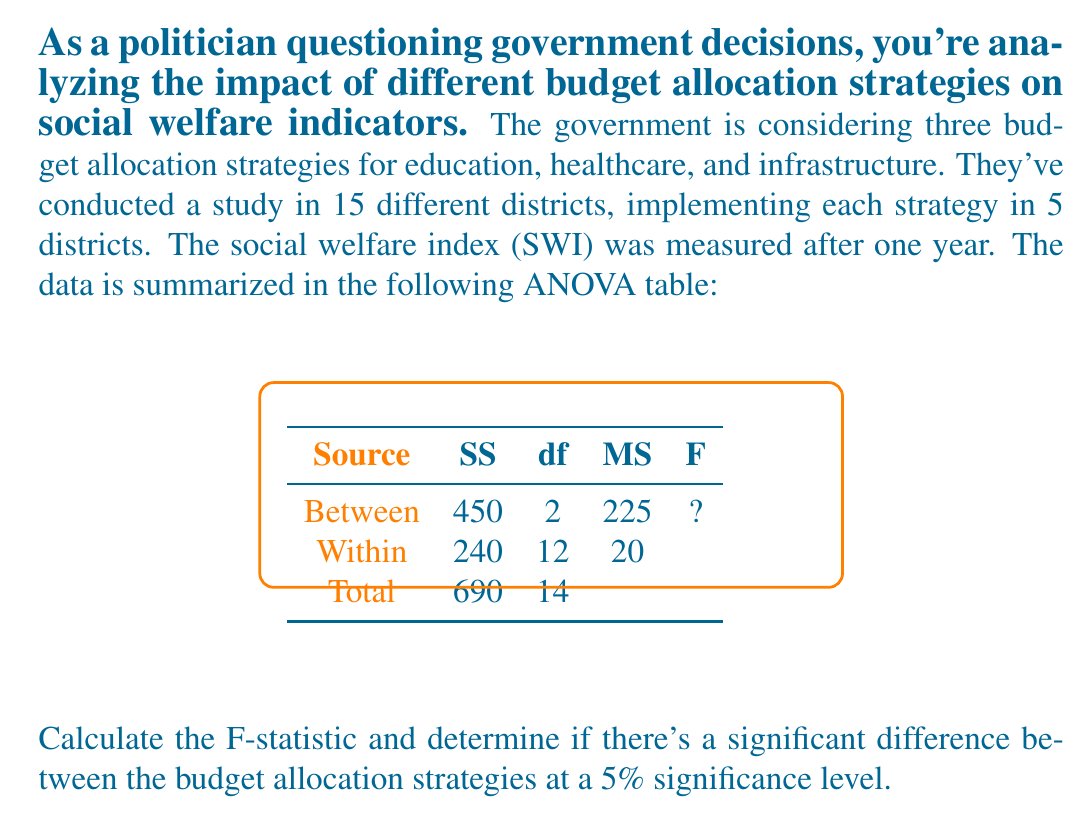Could you help me with this problem? Let's approach this step-by-step:

1) First, we need to calculate the F-statistic. The formula for F-statistic is:

   $$F = \frac{MS_{between}}{MS_{within}}$$

2) We can see from the ANOVA table that:
   $MS_{between} = 225$
   $MS_{within} = 20$

3) Plugging these values into the formula:

   $$F = \frac{225}{20} = 11.25$$

4) Now we need to determine the critical F-value to compare with our calculated F-statistic. For this, we need:
   - Significance level: α = 0.05 (5%)
   - Degrees of freedom: 
     - Numerator (between groups): $df_1 = 2$
     - Denominator (within groups): $df_2 = 12$

5) Using an F-distribution table or calculator with these parameters, we find:
   $F_{critical} (0.05, 2, 12) ≈ 3.89$

6) Decision rule:
   If $F_{calculated} > F_{critical}$, reject the null hypothesis.

7) Comparing:
   $F_{calculated} (11.25) > F_{critical} (3.89)$

Therefore, we reject the null hypothesis. This means there is a significant difference between the budget allocation strategies at the 5% significance level.
Answer: $F = 11.25$; Significant difference exists 